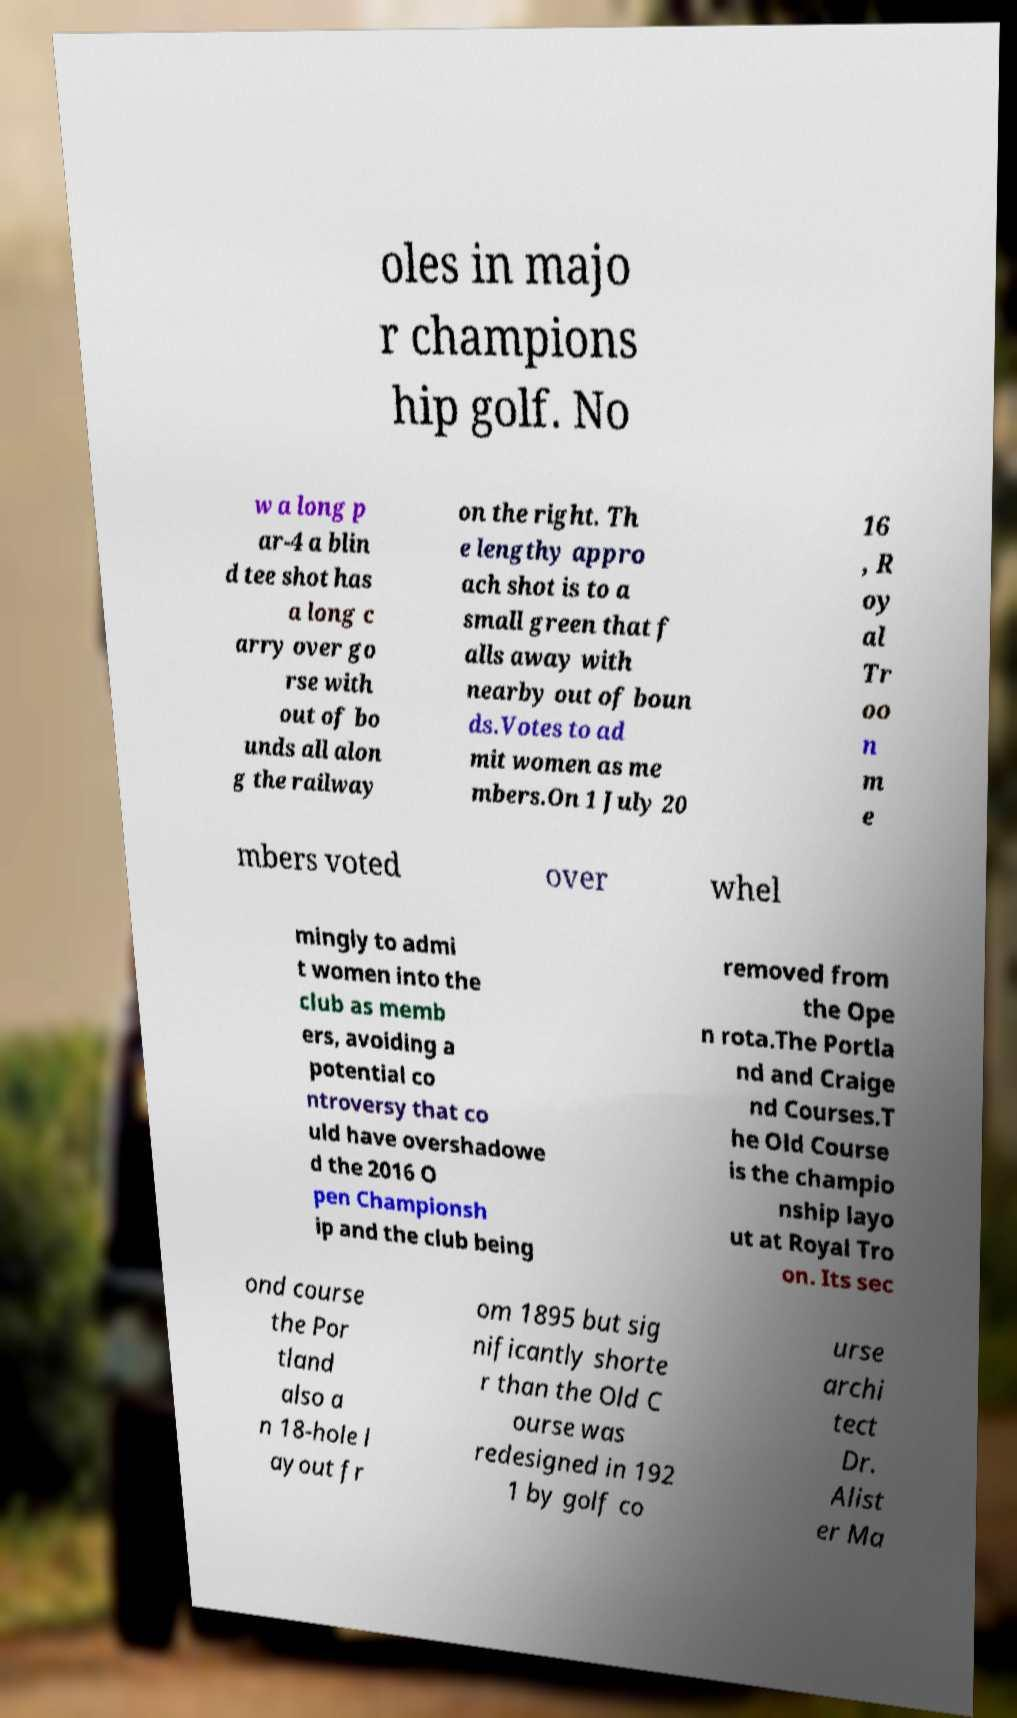Can you read and provide the text displayed in the image?This photo seems to have some interesting text. Can you extract and type it out for me? oles in majo r champions hip golf. No w a long p ar-4 a blin d tee shot has a long c arry over go rse with out of bo unds all alon g the railway on the right. Th e lengthy appro ach shot is to a small green that f alls away with nearby out of boun ds.Votes to ad mit women as me mbers.On 1 July 20 16 , R oy al Tr oo n m e mbers voted over whel mingly to admi t women into the club as memb ers, avoiding a potential co ntroversy that co uld have overshadowe d the 2016 O pen Championsh ip and the club being removed from the Ope n rota.The Portla nd and Craige nd Courses.T he Old Course is the champio nship layo ut at Royal Tro on. Its sec ond course the Por tland also a n 18-hole l ayout fr om 1895 but sig nificantly shorte r than the Old C ourse was redesigned in 192 1 by golf co urse archi tect Dr. Alist er Ma 